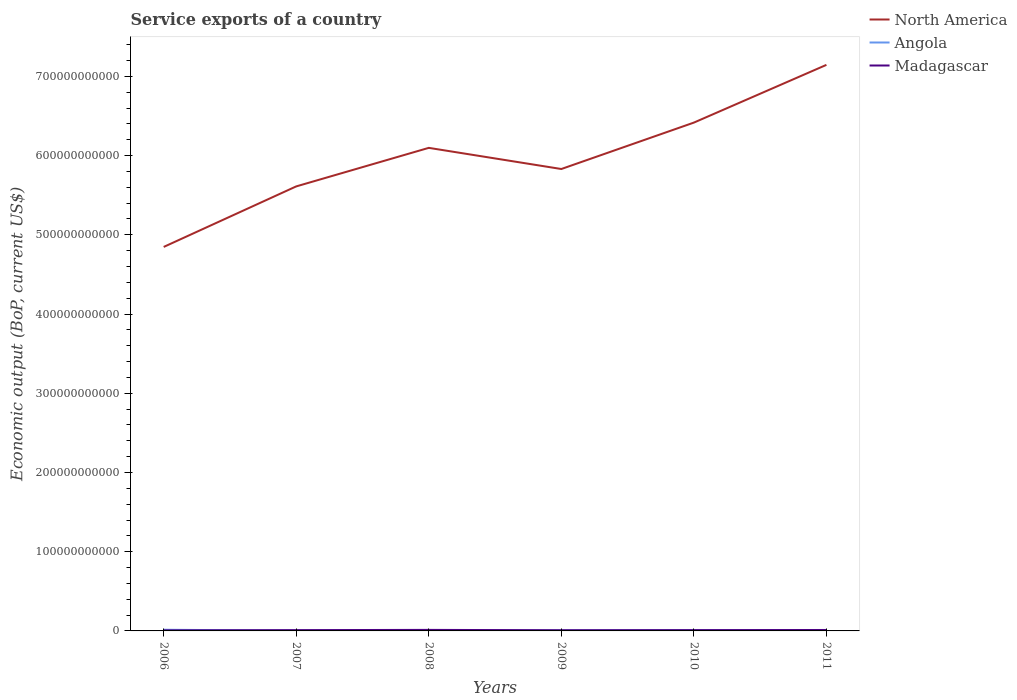Is the number of lines equal to the number of legend labels?
Offer a terse response. Yes. Across all years, what is the maximum service exports in North America?
Your answer should be very brief. 4.85e+11. In which year was the service exports in Angola maximum?
Your answer should be compact. 2007. What is the total service exports in North America in the graph?
Offer a very short reply. -1.31e+11. What is the difference between the highest and the second highest service exports in Madagascar?
Make the answer very short. 6.23e+08. Is the service exports in Madagascar strictly greater than the service exports in Angola over the years?
Provide a short and direct response. No. What is the difference between two consecutive major ticks on the Y-axis?
Ensure brevity in your answer.  1.00e+11. Are the values on the major ticks of Y-axis written in scientific E-notation?
Your answer should be very brief. No. Does the graph contain any zero values?
Keep it short and to the point. No. Does the graph contain grids?
Your response must be concise. No. How many legend labels are there?
Offer a terse response. 3. How are the legend labels stacked?
Your answer should be compact. Vertical. What is the title of the graph?
Make the answer very short. Service exports of a country. What is the label or title of the Y-axis?
Give a very brief answer. Economic output (BoP, current US$). What is the Economic output (BoP, current US$) of North America in 2006?
Provide a short and direct response. 4.85e+11. What is the Economic output (BoP, current US$) in Angola in 2006?
Offer a terse response. 1.48e+09. What is the Economic output (BoP, current US$) in Madagascar in 2006?
Make the answer very short. 6.73e+08. What is the Economic output (BoP, current US$) in North America in 2007?
Keep it short and to the point. 5.61e+11. What is the Economic output (BoP, current US$) in Angola in 2007?
Offer a very short reply. 3.11e+08. What is the Economic output (BoP, current US$) in Madagascar in 2007?
Offer a terse response. 9.99e+08. What is the Economic output (BoP, current US$) in North America in 2008?
Offer a terse response. 6.10e+11. What is the Economic output (BoP, current US$) of Angola in 2008?
Offer a terse response. 3.29e+08. What is the Economic output (BoP, current US$) of Madagascar in 2008?
Provide a short and direct response. 1.30e+09. What is the Economic output (BoP, current US$) of North America in 2009?
Offer a very short reply. 5.83e+11. What is the Economic output (BoP, current US$) of Angola in 2009?
Provide a succinct answer. 6.23e+08. What is the Economic output (BoP, current US$) of Madagascar in 2009?
Offer a terse response. 8.60e+08. What is the Economic output (BoP, current US$) in North America in 2010?
Your response must be concise. 6.42e+11. What is the Economic output (BoP, current US$) in Angola in 2010?
Provide a short and direct response. 8.57e+08. What is the Economic output (BoP, current US$) of Madagascar in 2010?
Offer a very short reply. 1.01e+09. What is the Economic output (BoP, current US$) of North America in 2011?
Your answer should be very brief. 7.15e+11. What is the Economic output (BoP, current US$) in Angola in 2011?
Provide a short and direct response. 7.32e+08. What is the Economic output (BoP, current US$) in Madagascar in 2011?
Your answer should be compact. 1.17e+09. Across all years, what is the maximum Economic output (BoP, current US$) of North America?
Offer a very short reply. 7.15e+11. Across all years, what is the maximum Economic output (BoP, current US$) in Angola?
Provide a short and direct response. 1.48e+09. Across all years, what is the maximum Economic output (BoP, current US$) in Madagascar?
Your answer should be compact. 1.30e+09. Across all years, what is the minimum Economic output (BoP, current US$) in North America?
Provide a short and direct response. 4.85e+11. Across all years, what is the minimum Economic output (BoP, current US$) in Angola?
Ensure brevity in your answer.  3.11e+08. Across all years, what is the minimum Economic output (BoP, current US$) in Madagascar?
Your answer should be compact. 6.73e+08. What is the total Economic output (BoP, current US$) of North America in the graph?
Your response must be concise. 3.59e+12. What is the total Economic output (BoP, current US$) of Angola in the graph?
Offer a very short reply. 4.34e+09. What is the total Economic output (BoP, current US$) of Madagascar in the graph?
Your answer should be compact. 6.01e+09. What is the difference between the Economic output (BoP, current US$) of North America in 2006 and that in 2007?
Make the answer very short. -7.64e+1. What is the difference between the Economic output (BoP, current US$) in Angola in 2006 and that in 2007?
Your answer should be compact. 1.17e+09. What is the difference between the Economic output (BoP, current US$) in Madagascar in 2006 and that in 2007?
Offer a very short reply. -3.26e+08. What is the difference between the Economic output (BoP, current US$) of North America in 2006 and that in 2008?
Offer a very short reply. -1.25e+11. What is the difference between the Economic output (BoP, current US$) of Angola in 2006 and that in 2008?
Your answer should be very brief. 1.15e+09. What is the difference between the Economic output (BoP, current US$) of Madagascar in 2006 and that in 2008?
Provide a succinct answer. -6.23e+08. What is the difference between the Economic output (BoP, current US$) in North America in 2006 and that in 2009?
Provide a short and direct response. -9.84e+1. What is the difference between the Economic output (BoP, current US$) of Angola in 2006 and that in 2009?
Your response must be concise. 8.61e+08. What is the difference between the Economic output (BoP, current US$) of Madagascar in 2006 and that in 2009?
Offer a terse response. -1.87e+08. What is the difference between the Economic output (BoP, current US$) of North America in 2006 and that in 2010?
Make the answer very short. -1.57e+11. What is the difference between the Economic output (BoP, current US$) in Angola in 2006 and that in 2010?
Give a very brief answer. 6.27e+08. What is the difference between the Economic output (BoP, current US$) in Madagascar in 2006 and that in 2010?
Offer a terse response. -3.39e+08. What is the difference between the Economic output (BoP, current US$) of North America in 2006 and that in 2011?
Your answer should be compact. -2.30e+11. What is the difference between the Economic output (BoP, current US$) of Angola in 2006 and that in 2011?
Your answer should be compact. 7.52e+08. What is the difference between the Economic output (BoP, current US$) in Madagascar in 2006 and that in 2011?
Offer a terse response. -5.00e+08. What is the difference between the Economic output (BoP, current US$) of North America in 2007 and that in 2008?
Offer a very short reply. -4.86e+1. What is the difference between the Economic output (BoP, current US$) of Angola in 2007 and that in 2008?
Offer a very short reply. -1.87e+07. What is the difference between the Economic output (BoP, current US$) in Madagascar in 2007 and that in 2008?
Provide a short and direct response. -2.97e+08. What is the difference between the Economic output (BoP, current US$) of North America in 2007 and that in 2009?
Offer a very short reply. -2.19e+1. What is the difference between the Economic output (BoP, current US$) of Angola in 2007 and that in 2009?
Your answer should be very brief. -3.12e+08. What is the difference between the Economic output (BoP, current US$) in Madagascar in 2007 and that in 2009?
Offer a very short reply. 1.40e+08. What is the difference between the Economic output (BoP, current US$) in North America in 2007 and that in 2010?
Your answer should be compact. -8.05e+1. What is the difference between the Economic output (BoP, current US$) in Angola in 2007 and that in 2010?
Your answer should be compact. -5.46e+08. What is the difference between the Economic output (BoP, current US$) of Madagascar in 2007 and that in 2010?
Provide a short and direct response. -1.25e+07. What is the difference between the Economic output (BoP, current US$) of North America in 2007 and that in 2011?
Ensure brevity in your answer.  -1.53e+11. What is the difference between the Economic output (BoP, current US$) of Angola in 2007 and that in 2011?
Your answer should be very brief. -4.22e+08. What is the difference between the Economic output (BoP, current US$) of Madagascar in 2007 and that in 2011?
Make the answer very short. -1.74e+08. What is the difference between the Economic output (BoP, current US$) of North America in 2008 and that in 2009?
Ensure brevity in your answer.  2.67e+1. What is the difference between the Economic output (BoP, current US$) of Angola in 2008 and that in 2009?
Offer a terse response. -2.94e+08. What is the difference between the Economic output (BoP, current US$) in Madagascar in 2008 and that in 2009?
Give a very brief answer. 4.37e+08. What is the difference between the Economic output (BoP, current US$) of North America in 2008 and that in 2010?
Keep it short and to the point. -3.19e+1. What is the difference between the Economic output (BoP, current US$) in Angola in 2008 and that in 2010?
Your response must be concise. -5.27e+08. What is the difference between the Economic output (BoP, current US$) in Madagascar in 2008 and that in 2010?
Provide a short and direct response. 2.85e+08. What is the difference between the Economic output (BoP, current US$) of North America in 2008 and that in 2011?
Offer a very short reply. -1.05e+11. What is the difference between the Economic output (BoP, current US$) of Angola in 2008 and that in 2011?
Your response must be concise. -4.03e+08. What is the difference between the Economic output (BoP, current US$) of Madagascar in 2008 and that in 2011?
Ensure brevity in your answer.  1.23e+08. What is the difference between the Economic output (BoP, current US$) in North America in 2009 and that in 2010?
Ensure brevity in your answer.  -5.86e+1. What is the difference between the Economic output (BoP, current US$) of Angola in 2009 and that in 2010?
Your response must be concise. -2.34e+08. What is the difference between the Economic output (BoP, current US$) of Madagascar in 2009 and that in 2010?
Keep it short and to the point. -1.52e+08. What is the difference between the Economic output (BoP, current US$) in North America in 2009 and that in 2011?
Make the answer very short. -1.31e+11. What is the difference between the Economic output (BoP, current US$) in Angola in 2009 and that in 2011?
Your answer should be compact. -1.09e+08. What is the difference between the Economic output (BoP, current US$) of Madagascar in 2009 and that in 2011?
Offer a terse response. -3.13e+08. What is the difference between the Economic output (BoP, current US$) of North America in 2010 and that in 2011?
Offer a terse response. -7.29e+1. What is the difference between the Economic output (BoP, current US$) in Angola in 2010 and that in 2011?
Offer a very short reply. 1.25e+08. What is the difference between the Economic output (BoP, current US$) in Madagascar in 2010 and that in 2011?
Provide a succinct answer. -1.61e+08. What is the difference between the Economic output (BoP, current US$) of North America in 2006 and the Economic output (BoP, current US$) of Angola in 2007?
Give a very brief answer. 4.84e+11. What is the difference between the Economic output (BoP, current US$) of North America in 2006 and the Economic output (BoP, current US$) of Madagascar in 2007?
Give a very brief answer. 4.84e+11. What is the difference between the Economic output (BoP, current US$) of Angola in 2006 and the Economic output (BoP, current US$) of Madagascar in 2007?
Provide a succinct answer. 4.85e+08. What is the difference between the Economic output (BoP, current US$) of North America in 2006 and the Economic output (BoP, current US$) of Angola in 2008?
Provide a succinct answer. 4.84e+11. What is the difference between the Economic output (BoP, current US$) in North America in 2006 and the Economic output (BoP, current US$) in Madagascar in 2008?
Provide a short and direct response. 4.83e+11. What is the difference between the Economic output (BoP, current US$) in Angola in 2006 and the Economic output (BoP, current US$) in Madagascar in 2008?
Provide a short and direct response. 1.88e+08. What is the difference between the Economic output (BoP, current US$) of North America in 2006 and the Economic output (BoP, current US$) of Angola in 2009?
Give a very brief answer. 4.84e+11. What is the difference between the Economic output (BoP, current US$) in North America in 2006 and the Economic output (BoP, current US$) in Madagascar in 2009?
Make the answer very short. 4.84e+11. What is the difference between the Economic output (BoP, current US$) of Angola in 2006 and the Economic output (BoP, current US$) of Madagascar in 2009?
Your answer should be very brief. 6.25e+08. What is the difference between the Economic output (BoP, current US$) in North America in 2006 and the Economic output (BoP, current US$) in Angola in 2010?
Offer a terse response. 4.84e+11. What is the difference between the Economic output (BoP, current US$) of North America in 2006 and the Economic output (BoP, current US$) of Madagascar in 2010?
Ensure brevity in your answer.  4.84e+11. What is the difference between the Economic output (BoP, current US$) in Angola in 2006 and the Economic output (BoP, current US$) in Madagascar in 2010?
Your response must be concise. 4.72e+08. What is the difference between the Economic output (BoP, current US$) of North America in 2006 and the Economic output (BoP, current US$) of Angola in 2011?
Ensure brevity in your answer.  4.84e+11. What is the difference between the Economic output (BoP, current US$) in North America in 2006 and the Economic output (BoP, current US$) in Madagascar in 2011?
Your answer should be compact. 4.84e+11. What is the difference between the Economic output (BoP, current US$) in Angola in 2006 and the Economic output (BoP, current US$) in Madagascar in 2011?
Your response must be concise. 3.11e+08. What is the difference between the Economic output (BoP, current US$) of North America in 2007 and the Economic output (BoP, current US$) of Angola in 2008?
Your answer should be very brief. 5.61e+11. What is the difference between the Economic output (BoP, current US$) in North America in 2007 and the Economic output (BoP, current US$) in Madagascar in 2008?
Make the answer very short. 5.60e+11. What is the difference between the Economic output (BoP, current US$) of Angola in 2007 and the Economic output (BoP, current US$) of Madagascar in 2008?
Your answer should be compact. -9.86e+08. What is the difference between the Economic output (BoP, current US$) of North America in 2007 and the Economic output (BoP, current US$) of Angola in 2009?
Offer a very short reply. 5.61e+11. What is the difference between the Economic output (BoP, current US$) in North America in 2007 and the Economic output (BoP, current US$) in Madagascar in 2009?
Keep it short and to the point. 5.60e+11. What is the difference between the Economic output (BoP, current US$) of Angola in 2007 and the Economic output (BoP, current US$) of Madagascar in 2009?
Offer a terse response. -5.49e+08. What is the difference between the Economic output (BoP, current US$) in North America in 2007 and the Economic output (BoP, current US$) in Angola in 2010?
Give a very brief answer. 5.60e+11. What is the difference between the Economic output (BoP, current US$) in North America in 2007 and the Economic output (BoP, current US$) in Madagascar in 2010?
Your answer should be compact. 5.60e+11. What is the difference between the Economic output (BoP, current US$) of Angola in 2007 and the Economic output (BoP, current US$) of Madagascar in 2010?
Your answer should be compact. -7.01e+08. What is the difference between the Economic output (BoP, current US$) in North America in 2007 and the Economic output (BoP, current US$) in Angola in 2011?
Your answer should be compact. 5.60e+11. What is the difference between the Economic output (BoP, current US$) in North America in 2007 and the Economic output (BoP, current US$) in Madagascar in 2011?
Give a very brief answer. 5.60e+11. What is the difference between the Economic output (BoP, current US$) in Angola in 2007 and the Economic output (BoP, current US$) in Madagascar in 2011?
Keep it short and to the point. -8.62e+08. What is the difference between the Economic output (BoP, current US$) of North America in 2008 and the Economic output (BoP, current US$) of Angola in 2009?
Give a very brief answer. 6.09e+11. What is the difference between the Economic output (BoP, current US$) of North America in 2008 and the Economic output (BoP, current US$) of Madagascar in 2009?
Offer a very short reply. 6.09e+11. What is the difference between the Economic output (BoP, current US$) of Angola in 2008 and the Economic output (BoP, current US$) of Madagascar in 2009?
Offer a very short reply. -5.30e+08. What is the difference between the Economic output (BoP, current US$) in North America in 2008 and the Economic output (BoP, current US$) in Angola in 2010?
Keep it short and to the point. 6.09e+11. What is the difference between the Economic output (BoP, current US$) in North America in 2008 and the Economic output (BoP, current US$) in Madagascar in 2010?
Make the answer very short. 6.09e+11. What is the difference between the Economic output (BoP, current US$) of Angola in 2008 and the Economic output (BoP, current US$) of Madagascar in 2010?
Ensure brevity in your answer.  -6.82e+08. What is the difference between the Economic output (BoP, current US$) in North America in 2008 and the Economic output (BoP, current US$) in Angola in 2011?
Provide a short and direct response. 6.09e+11. What is the difference between the Economic output (BoP, current US$) in North America in 2008 and the Economic output (BoP, current US$) in Madagascar in 2011?
Ensure brevity in your answer.  6.09e+11. What is the difference between the Economic output (BoP, current US$) of Angola in 2008 and the Economic output (BoP, current US$) of Madagascar in 2011?
Make the answer very short. -8.44e+08. What is the difference between the Economic output (BoP, current US$) in North America in 2009 and the Economic output (BoP, current US$) in Angola in 2010?
Provide a short and direct response. 5.82e+11. What is the difference between the Economic output (BoP, current US$) in North America in 2009 and the Economic output (BoP, current US$) in Madagascar in 2010?
Ensure brevity in your answer.  5.82e+11. What is the difference between the Economic output (BoP, current US$) in Angola in 2009 and the Economic output (BoP, current US$) in Madagascar in 2010?
Make the answer very short. -3.89e+08. What is the difference between the Economic output (BoP, current US$) of North America in 2009 and the Economic output (BoP, current US$) of Angola in 2011?
Provide a succinct answer. 5.82e+11. What is the difference between the Economic output (BoP, current US$) in North America in 2009 and the Economic output (BoP, current US$) in Madagascar in 2011?
Provide a succinct answer. 5.82e+11. What is the difference between the Economic output (BoP, current US$) of Angola in 2009 and the Economic output (BoP, current US$) of Madagascar in 2011?
Your answer should be very brief. -5.50e+08. What is the difference between the Economic output (BoP, current US$) in North America in 2010 and the Economic output (BoP, current US$) in Angola in 2011?
Provide a succinct answer. 6.41e+11. What is the difference between the Economic output (BoP, current US$) of North America in 2010 and the Economic output (BoP, current US$) of Madagascar in 2011?
Keep it short and to the point. 6.40e+11. What is the difference between the Economic output (BoP, current US$) of Angola in 2010 and the Economic output (BoP, current US$) of Madagascar in 2011?
Offer a terse response. -3.16e+08. What is the average Economic output (BoP, current US$) of North America per year?
Make the answer very short. 5.99e+11. What is the average Economic output (BoP, current US$) in Angola per year?
Make the answer very short. 7.23e+08. What is the average Economic output (BoP, current US$) of Madagascar per year?
Make the answer very short. 1.00e+09. In the year 2006, what is the difference between the Economic output (BoP, current US$) in North America and Economic output (BoP, current US$) in Angola?
Your answer should be very brief. 4.83e+11. In the year 2006, what is the difference between the Economic output (BoP, current US$) in North America and Economic output (BoP, current US$) in Madagascar?
Make the answer very short. 4.84e+11. In the year 2006, what is the difference between the Economic output (BoP, current US$) in Angola and Economic output (BoP, current US$) in Madagascar?
Ensure brevity in your answer.  8.11e+08. In the year 2007, what is the difference between the Economic output (BoP, current US$) in North America and Economic output (BoP, current US$) in Angola?
Make the answer very short. 5.61e+11. In the year 2007, what is the difference between the Economic output (BoP, current US$) in North America and Economic output (BoP, current US$) in Madagascar?
Your answer should be compact. 5.60e+11. In the year 2007, what is the difference between the Economic output (BoP, current US$) of Angola and Economic output (BoP, current US$) of Madagascar?
Give a very brief answer. -6.89e+08. In the year 2008, what is the difference between the Economic output (BoP, current US$) in North America and Economic output (BoP, current US$) in Angola?
Provide a short and direct response. 6.09e+11. In the year 2008, what is the difference between the Economic output (BoP, current US$) of North America and Economic output (BoP, current US$) of Madagascar?
Provide a succinct answer. 6.08e+11. In the year 2008, what is the difference between the Economic output (BoP, current US$) of Angola and Economic output (BoP, current US$) of Madagascar?
Provide a succinct answer. -9.67e+08. In the year 2009, what is the difference between the Economic output (BoP, current US$) in North America and Economic output (BoP, current US$) in Angola?
Your response must be concise. 5.82e+11. In the year 2009, what is the difference between the Economic output (BoP, current US$) in North America and Economic output (BoP, current US$) in Madagascar?
Keep it short and to the point. 5.82e+11. In the year 2009, what is the difference between the Economic output (BoP, current US$) of Angola and Economic output (BoP, current US$) of Madagascar?
Ensure brevity in your answer.  -2.36e+08. In the year 2010, what is the difference between the Economic output (BoP, current US$) in North America and Economic output (BoP, current US$) in Angola?
Provide a short and direct response. 6.41e+11. In the year 2010, what is the difference between the Economic output (BoP, current US$) of North America and Economic output (BoP, current US$) of Madagascar?
Offer a terse response. 6.41e+11. In the year 2010, what is the difference between the Economic output (BoP, current US$) of Angola and Economic output (BoP, current US$) of Madagascar?
Provide a succinct answer. -1.55e+08. In the year 2011, what is the difference between the Economic output (BoP, current US$) in North America and Economic output (BoP, current US$) in Angola?
Keep it short and to the point. 7.14e+11. In the year 2011, what is the difference between the Economic output (BoP, current US$) in North America and Economic output (BoP, current US$) in Madagascar?
Your answer should be compact. 7.13e+11. In the year 2011, what is the difference between the Economic output (BoP, current US$) of Angola and Economic output (BoP, current US$) of Madagascar?
Provide a short and direct response. -4.41e+08. What is the ratio of the Economic output (BoP, current US$) of North America in 2006 to that in 2007?
Your answer should be very brief. 0.86. What is the ratio of the Economic output (BoP, current US$) in Angola in 2006 to that in 2007?
Your answer should be very brief. 4.78. What is the ratio of the Economic output (BoP, current US$) of Madagascar in 2006 to that in 2007?
Keep it short and to the point. 0.67. What is the ratio of the Economic output (BoP, current US$) of North America in 2006 to that in 2008?
Ensure brevity in your answer.  0.79. What is the ratio of the Economic output (BoP, current US$) of Angola in 2006 to that in 2008?
Ensure brevity in your answer.  4.51. What is the ratio of the Economic output (BoP, current US$) of Madagascar in 2006 to that in 2008?
Offer a terse response. 0.52. What is the ratio of the Economic output (BoP, current US$) of North America in 2006 to that in 2009?
Provide a short and direct response. 0.83. What is the ratio of the Economic output (BoP, current US$) of Angola in 2006 to that in 2009?
Give a very brief answer. 2.38. What is the ratio of the Economic output (BoP, current US$) of Madagascar in 2006 to that in 2009?
Provide a short and direct response. 0.78. What is the ratio of the Economic output (BoP, current US$) of North America in 2006 to that in 2010?
Keep it short and to the point. 0.76. What is the ratio of the Economic output (BoP, current US$) in Angola in 2006 to that in 2010?
Your answer should be very brief. 1.73. What is the ratio of the Economic output (BoP, current US$) of Madagascar in 2006 to that in 2010?
Ensure brevity in your answer.  0.67. What is the ratio of the Economic output (BoP, current US$) of North America in 2006 to that in 2011?
Offer a terse response. 0.68. What is the ratio of the Economic output (BoP, current US$) in Angola in 2006 to that in 2011?
Provide a succinct answer. 2.03. What is the ratio of the Economic output (BoP, current US$) in Madagascar in 2006 to that in 2011?
Give a very brief answer. 0.57. What is the ratio of the Economic output (BoP, current US$) in North America in 2007 to that in 2008?
Your response must be concise. 0.92. What is the ratio of the Economic output (BoP, current US$) of Angola in 2007 to that in 2008?
Offer a very short reply. 0.94. What is the ratio of the Economic output (BoP, current US$) in Madagascar in 2007 to that in 2008?
Ensure brevity in your answer.  0.77. What is the ratio of the Economic output (BoP, current US$) of North America in 2007 to that in 2009?
Offer a very short reply. 0.96. What is the ratio of the Economic output (BoP, current US$) of Angola in 2007 to that in 2009?
Your answer should be compact. 0.5. What is the ratio of the Economic output (BoP, current US$) of Madagascar in 2007 to that in 2009?
Offer a terse response. 1.16. What is the ratio of the Economic output (BoP, current US$) in North America in 2007 to that in 2010?
Ensure brevity in your answer.  0.87. What is the ratio of the Economic output (BoP, current US$) in Angola in 2007 to that in 2010?
Your answer should be very brief. 0.36. What is the ratio of the Economic output (BoP, current US$) in Madagascar in 2007 to that in 2010?
Your response must be concise. 0.99. What is the ratio of the Economic output (BoP, current US$) of North America in 2007 to that in 2011?
Your response must be concise. 0.79. What is the ratio of the Economic output (BoP, current US$) in Angola in 2007 to that in 2011?
Keep it short and to the point. 0.42. What is the ratio of the Economic output (BoP, current US$) in Madagascar in 2007 to that in 2011?
Offer a terse response. 0.85. What is the ratio of the Economic output (BoP, current US$) in North America in 2008 to that in 2009?
Give a very brief answer. 1.05. What is the ratio of the Economic output (BoP, current US$) in Angola in 2008 to that in 2009?
Provide a short and direct response. 0.53. What is the ratio of the Economic output (BoP, current US$) in Madagascar in 2008 to that in 2009?
Provide a short and direct response. 1.51. What is the ratio of the Economic output (BoP, current US$) in North America in 2008 to that in 2010?
Offer a very short reply. 0.95. What is the ratio of the Economic output (BoP, current US$) of Angola in 2008 to that in 2010?
Your answer should be very brief. 0.38. What is the ratio of the Economic output (BoP, current US$) in Madagascar in 2008 to that in 2010?
Offer a very short reply. 1.28. What is the ratio of the Economic output (BoP, current US$) in North America in 2008 to that in 2011?
Offer a very short reply. 0.85. What is the ratio of the Economic output (BoP, current US$) in Angola in 2008 to that in 2011?
Give a very brief answer. 0.45. What is the ratio of the Economic output (BoP, current US$) of Madagascar in 2008 to that in 2011?
Your response must be concise. 1.11. What is the ratio of the Economic output (BoP, current US$) of North America in 2009 to that in 2010?
Make the answer very short. 0.91. What is the ratio of the Economic output (BoP, current US$) of Angola in 2009 to that in 2010?
Provide a short and direct response. 0.73. What is the ratio of the Economic output (BoP, current US$) in Madagascar in 2009 to that in 2010?
Offer a terse response. 0.85. What is the ratio of the Economic output (BoP, current US$) of North America in 2009 to that in 2011?
Your response must be concise. 0.82. What is the ratio of the Economic output (BoP, current US$) of Angola in 2009 to that in 2011?
Give a very brief answer. 0.85. What is the ratio of the Economic output (BoP, current US$) in Madagascar in 2009 to that in 2011?
Your response must be concise. 0.73. What is the ratio of the Economic output (BoP, current US$) in North America in 2010 to that in 2011?
Your answer should be compact. 0.9. What is the ratio of the Economic output (BoP, current US$) of Angola in 2010 to that in 2011?
Offer a very short reply. 1.17. What is the ratio of the Economic output (BoP, current US$) of Madagascar in 2010 to that in 2011?
Ensure brevity in your answer.  0.86. What is the difference between the highest and the second highest Economic output (BoP, current US$) of North America?
Provide a succinct answer. 7.29e+1. What is the difference between the highest and the second highest Economic output (BoP, current US$) in Angola?
Ensure brevity in your answer.  6.27e+08. What is the difference between the highest and the second highest Economic output (BoP, current US$) in Madagascar?
Your response must be concise. 1.23e+08. What is the difference between the highest and the lowest Economic output (BoP, current US$) in North America?
Make the answer very short. 2.30e+11. What is the difference between the highest and the lowest Economic output (BoP, current US$) of Angola?
Make the answer very short. 1.17e+09. What is the difference between the highest and the lowest Economic output (BoP, current US$) in Madagascar?
Your answer should be compact. 6.23e+08. 